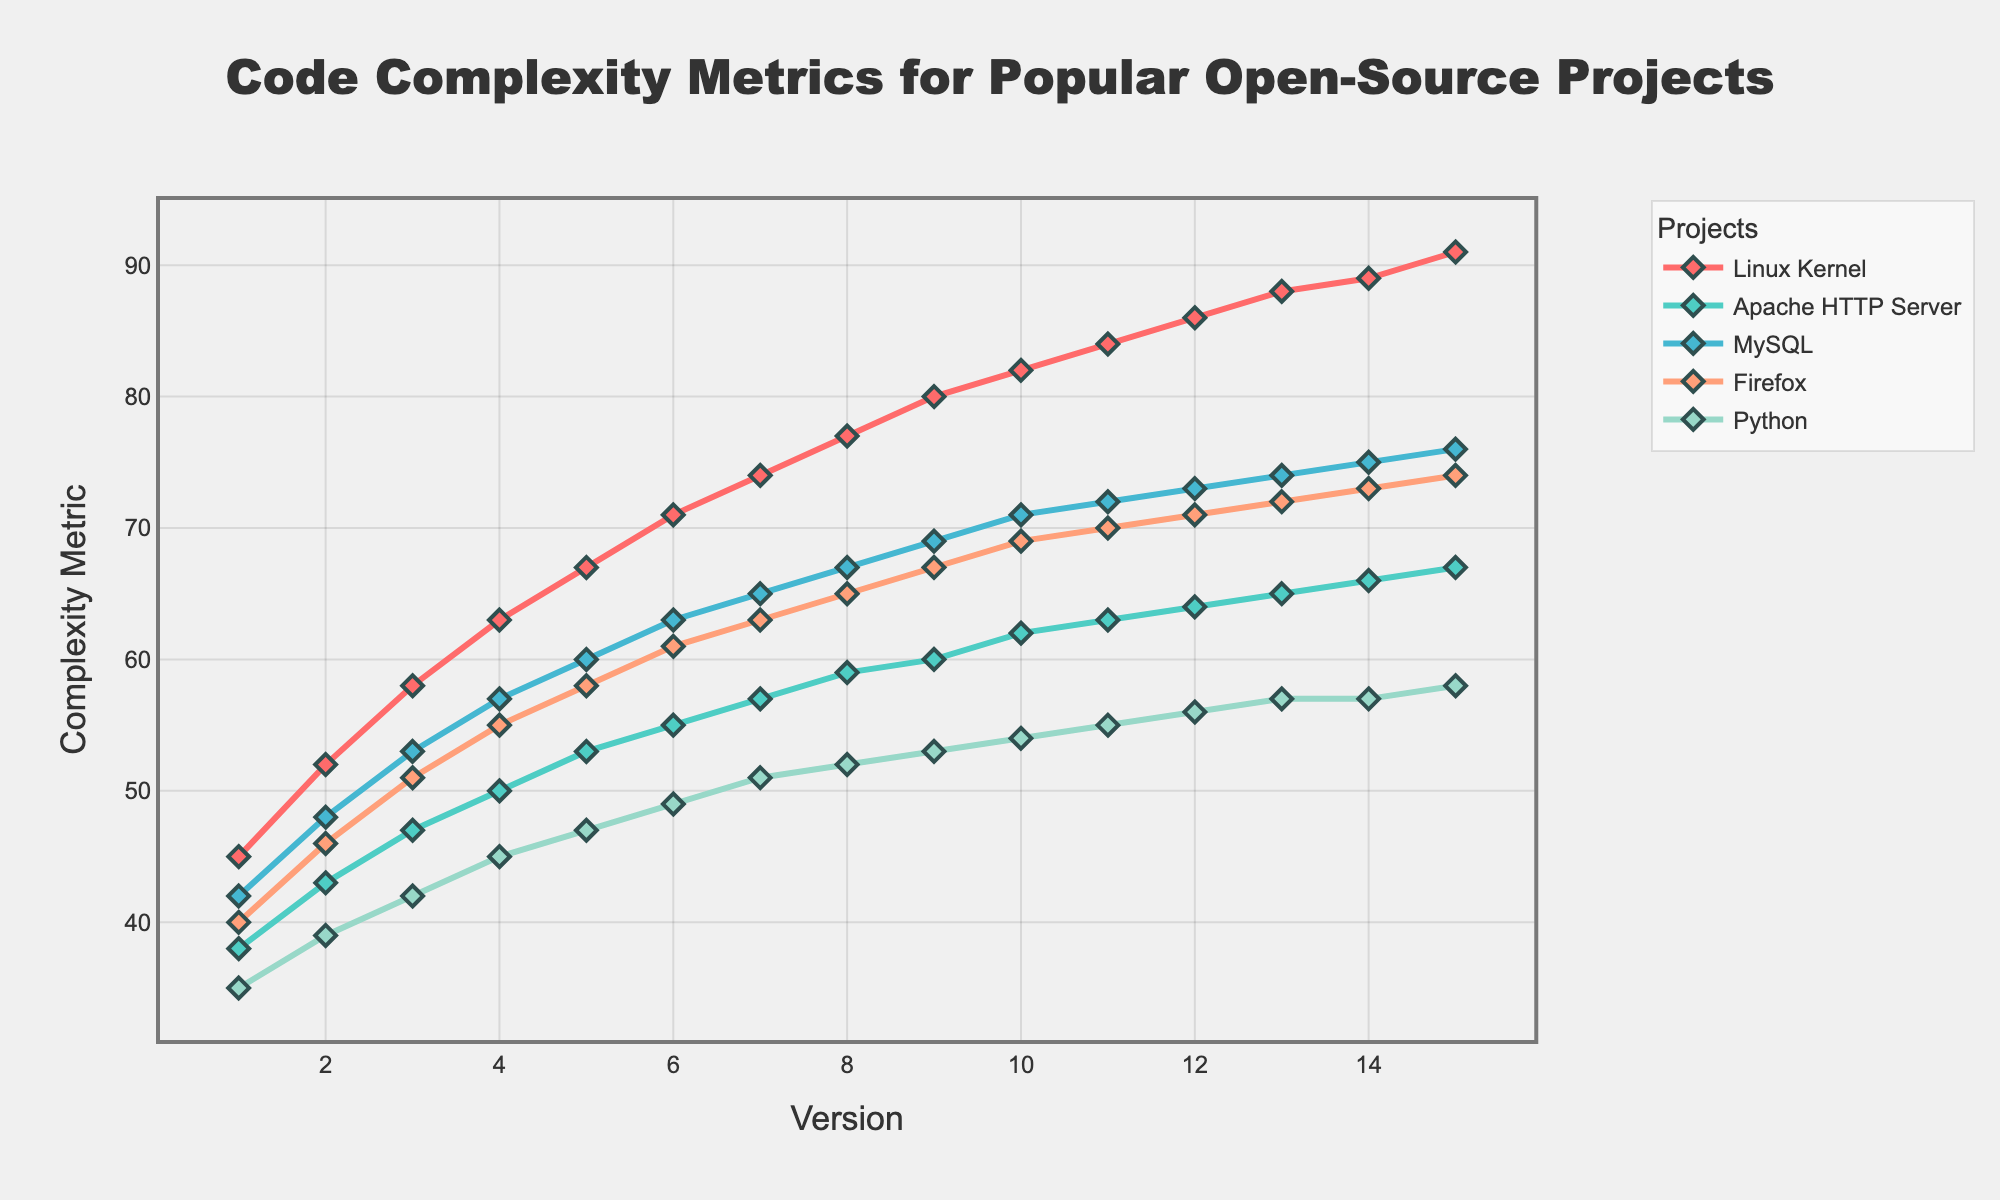what is the difference in complexity metrics between version 10.0 and version 1.0 for the Linux Kernel? To find the difference, subtract the complexity metric of version 1.0 (45) from version 10.0 (82). So, 82 - 45 = 37.
Answer: 37 which project has the lowest complexity metric in version 8.0? In version 8.0, the complexity metrics for the projects are: Linux Kernel (77), Apache HTTP Server (59), MySQL (67), Firefox (65), Python (52). Python has the lowest complexity metric of 52.
Answer: Python in which version does Firefox reach a complexity metric of 73? Observing the Firefox's line in the chart, it reaches a complexity metric of 73 at version 12.0.
Answer: version 12.0 does MySQL or Apache HTTP Server have a greater increase in complexity from version 3.0 to version 7.0? Calculate the increase for MySQL: 65 (7.0) - 53 (3.0) = 12. Calculate the increase for Apache HTTP Server: 57 (7.0) - 47 (3.0) = 10. MySQL has a greater increase of 12 compared to Apache HTTP Server's 10.
Answer: MySQL what is the average complexity metric of Python across all versions? Sum all the complexity metrics for Python (35 + 39 + 42 + 45 + 47 + 49 + 51 + 52 + 53 + 54 + 55 + 56 + 57 + 57 + 58) = 750. There are 15 versions, so the average is 750 / 15 = 50.
Answer: 50 between versions 5.0 and 10.0, which project shows a more rapid increase in complexity: Linux Kernel or Firefox? Calculate the increase for Linux Kernel: 82 (10.0) - 67 (5.0) = 15. Calculate the increase for Firefox: 69 (10.0) - 58 (5.0) = 11. The Linux Kernel shows a more rapid increase with 15 compared to Firefox's 11.
Answer: Linux Kernel how does the complexity metric of MySQL in version 6.0 compare to that of Apache HTTP Server in version 9.0? The complexity metric of MySQL in version 6.0 is 63. The complexity metric of Apache HTTP Server in version 9.0 is 60. Thus, MySQL's complexity metric in version 6.0 is greater than Apache HTTP Server's in version 9.0.
Answer: MySQL is greater what is the sum of the complexity metrics for Apache HTTP Server across versions 1.0 and 15.0? The complexity metric for Apache HTTP Server in version 1.0 is 38, and in version 15.0 it is 67. Sum them up: 38 + 67 = 105.
Answer: 105 which project shows the least fluctuation in complexity metric across all versions? By observing the lines, Python's complexity metric shows the least fluctuation as it has the smoothest and least steeply inclined line over the versions.
Answer: Python 